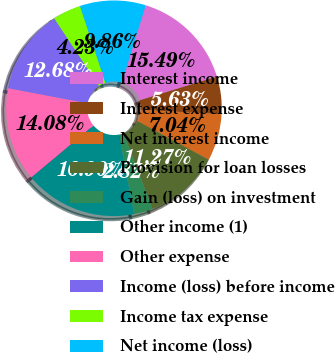<chart> <loc_0><loc_0><loc_500><loc_500><pie_chart><fcel>Interest income<fcel>Interest expense<fcel>Net interest income<fcel>Provision for loan losses<fcel>Gain (loss) on investment<fcel>Other income (1)<fcel>Other expense<fcel>Income (loss) before income<fcel>Income tax expense<fcel>Net income (loss)<nl><fcel>15.49%<fcel>5.63%<fcel>7.04%<fcel>11.27%<fcel>2.82%<fcel>16.9%<fcel>14.08%<fcel>12.68%<fcel>4.23%<fcel>9.86%<nl></chart> 